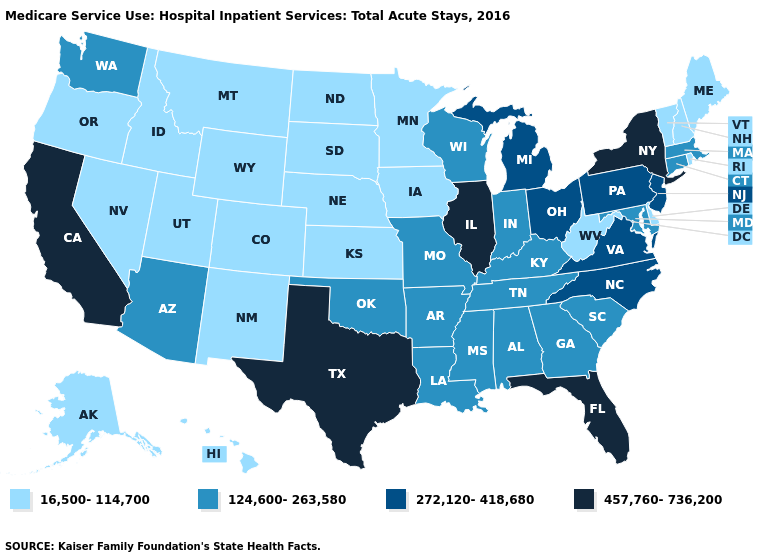Name the states that have a value in the range 16,500-114,700?
Short answer required. Alaska, Colorado, Delaware, Hawaii, Idaho, Iowa, Kansas, Maine, Minnesota, Montana, Nebraska, Nevada, New Hampshire, New Mexico, North Dakota, Oregon, Rhode Island, South Dakota, Utah, Vermont, West Virginia, Wyoming. Which states hav the highest value in the West?
Be succinct. California. What is the value of Maryland?
Write a very short answer. 124,600-263,580. What is the value of California?
Concise answer only. 457,760-736,200. Name the states that have a value in the range 124,600-263,580?
Be succinct. Alabama, Arizona, Arkansas, Connecticut, Georgia, Indiana, Kentucky, Louisiana, Maryland, Massachusetts, Mississippi, Missouri, Oklahoma, South Carolina, Tennessee, Washington, Wisconsin. Among the states that border Maryland , does Delaware have the highest value?
Keep it brief. No. Name the states that have a value in the range 16,500-114,700?
Concise answer only. Alaska, Colorado, Delaware, Hawaii, Idaho, Iowa, Kansas, Maine, Minnesota, Montana, Nebraska, Nevada, New Hampshire, New Mexico, North Dakota, Oregon, Rhode Island, South Dakota, Utah, Vermont, West Virginia, Wyoming. What is the value of Virginia?
Write a very short answer. 272,120-418,680. What is the value of Arizona?
Be succinct. 124,600-263,580. Does Maine have the lowest value in the USA?
Answer briefly. Yes. Among the states that border Georgia , does Florida have the highest value?
Give a very brief answer. Yes. Which states hav the highest value in the Northeast?
Short answer required. New York. Name the states that have a value in the range 457,760-736,200?
Concise answer only. California, Florida, Illinois, New York, Texas. Is the legend a continuous bar?
Answer briefly. No. Name the states that have a value in the range 272,120-418,680?
Quick response, please. Michigan, New Jersey, North Carolina, Ohio, Pennsylvania, Virginia. 